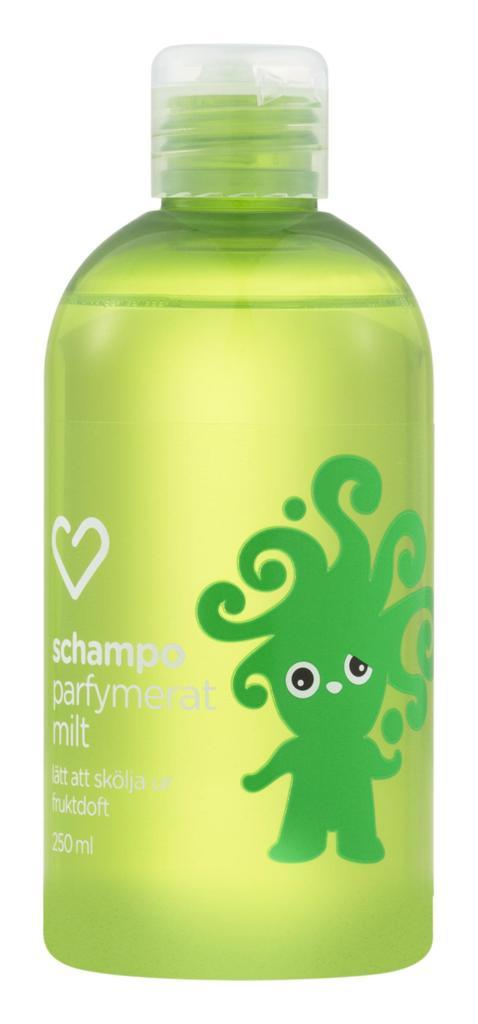How many milliliters are in this bottle?
Make the answer very short. 250. 